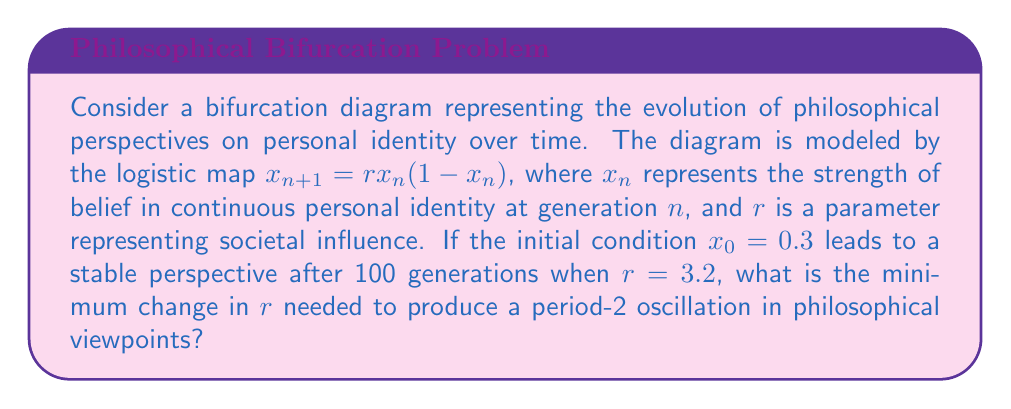Provide a solution to this math problem. 1. For the logistic map $x_{n+1} = rx_n(1-x_n)$, we know that:
   - For $1 < r < 3$, the system converges to a single fixed point.
   - At $r = 3$, the system undergoes its first bifurcation.
   - For $3 < r < 1+\sqrt{6} \approx 3.449$, the system oscillates between two values (period-2).

2. Given $r = 3.2$ leads to a stable perspective, we need to find the minimum increase in $r$ to reach the period-2 regime.

3. The exact bifurcation point occurs at $r = 3$. Since $r = 3.2$ is already in the period-2 regime, we need to find the minimum decrease in $r$ to reach the bifurcation point.

4. The change needed is:
   $$\Delta r = 3.2 - 3 = 0.2$$

5. This represents the minimum change required to transition from a stable perspective to a period-2 oscillation.

6. To verify, we can iterate the map for both $r = 3.2$ and $r = 3$:

   For $r = 3.2$:
   $$x_{100} \approx 0.7994$$
   $$x_{101} \approx 0.5130$$
   $$x_{102} \approx 0.7994$$

   For $r = 3$:
   $$x_{100} \approx 0.6667$$
   $$x_{101} \approx 0.6667$$
   $$x_{102} \approx 0.6667$$

   This confirms that $r = 3.2$ produces a period-2 oscillation, while $r = 3$ converges to a fixed point.
Answer: 0.2 